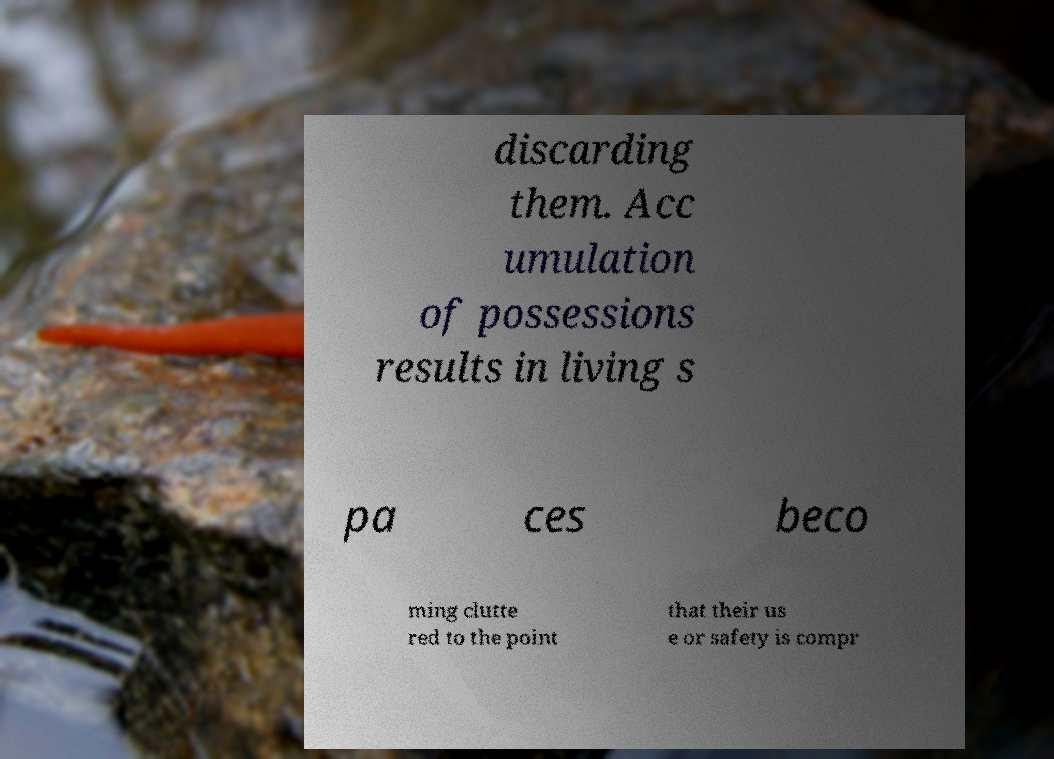Could you assist in decoding the text presented in this image and type it out clearly? discarding them. Acc umulation of possessions results in living s pa ces beco ming clutte red to the point that their us e or safety is compr 